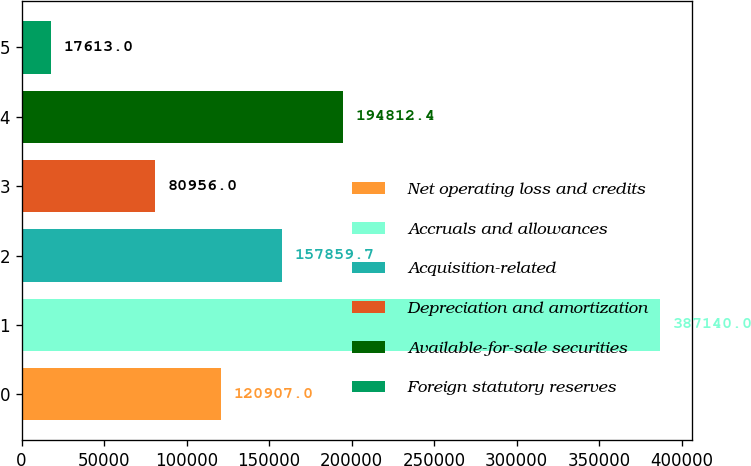Convert chart to OTSL. <chart><loc_0><loc_0><loc_500><loc_500><bar_chart><fcel>Net operating loss and credits<fcel>Accruals and allowances<fcel>Acquisition-related<fcel>Depreciation and amortization<fcel>Available-for-sale securities<fcel>Foreign statutory reserves<nl><fcel>120907<fcel>387140<fcel>157860<fcel>80956<fcel>194812<fcel>17613<nl></chart> 